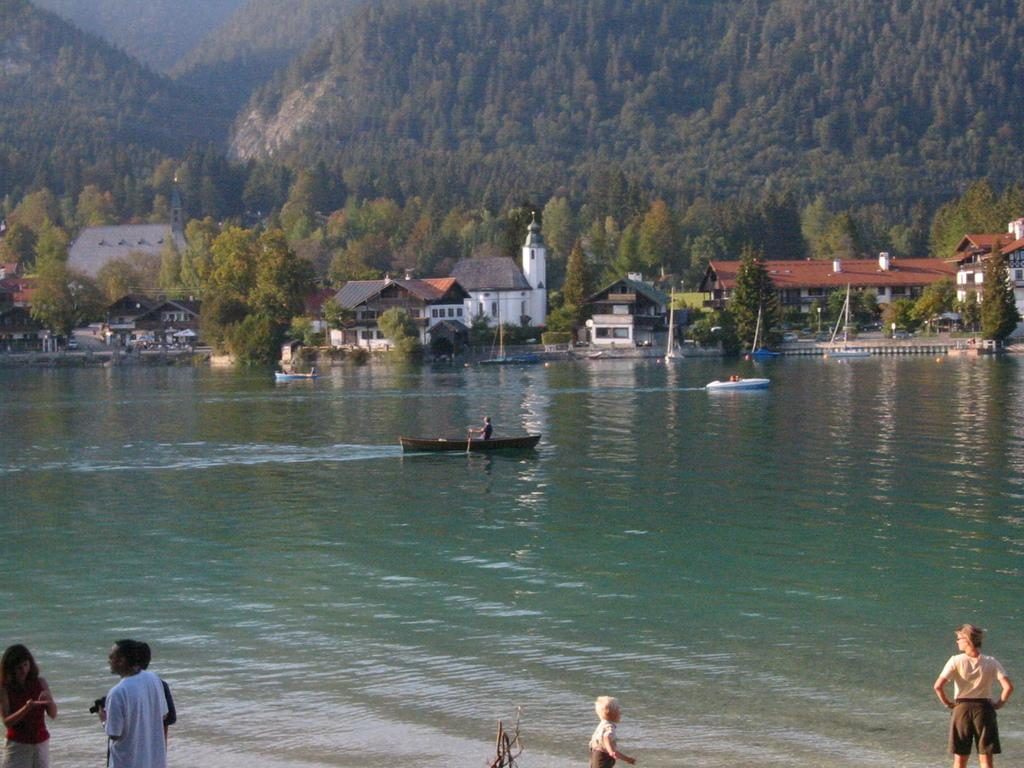How many people are in the image? There are people in the image, but the exact number is not specified. What are the people doing in the image? Some people are on boats in the image. Where are the boats located in the image? The boats are on the water in the image. What can be seen in the background of the image? There are trees, buildings, and other objects visible in the background of the image. Can you describe the haircut of the person on the boat? There is no information about the haircuts of the people in the image, as the focus is on their activities and the boats. Is there any smoke coming from the buildings in the background? There is no mention of smoke in the image, so it cannot be determined if there is any coming from the buildings. 